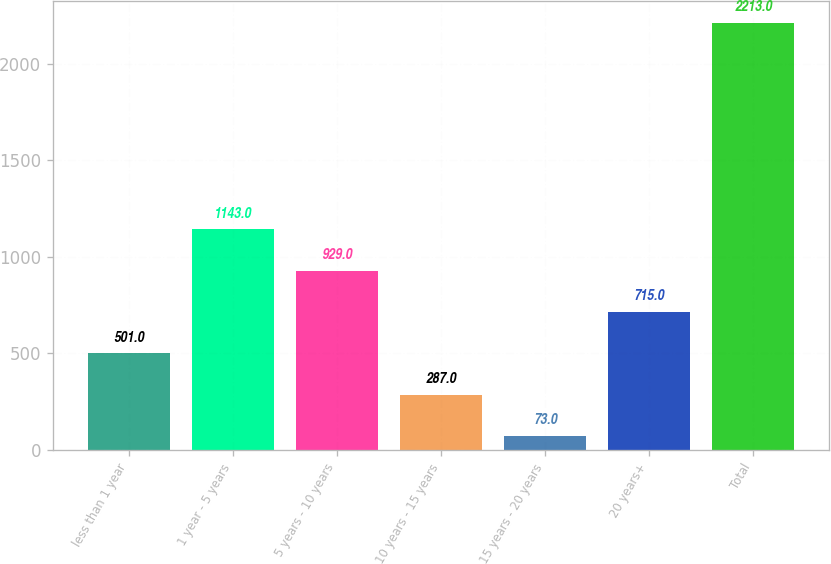Convert chart. <chart><loc_0><loc_0><loc_500><loc_500><bar_chart><fcel>less than 1 year<fcel>1 year - 5 years<fcel>5 years - 10 years<fcel>10 years - 15 years<fcel>15 years - 20 years<fcel>20 years+<fcel>Total<nl><fcel>501<fcel>1143<fcel>929<fcel>287<fcel>73<fcel>715<fcel>2213<nl></chart> 